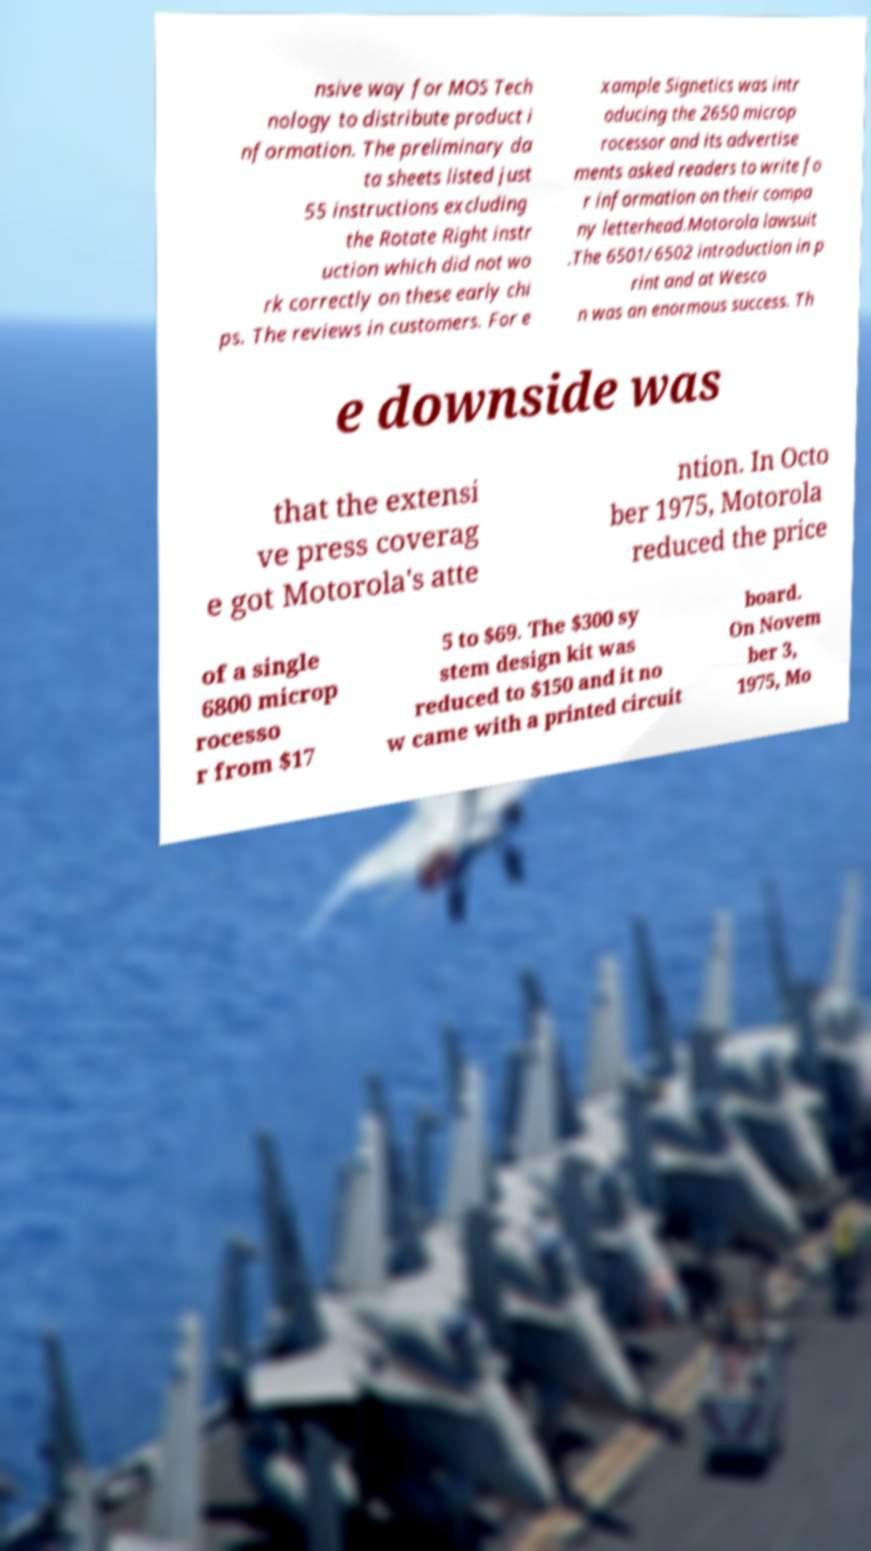Could you extract and type out the text from this image? nsive way for MOS Tech nology to distribute product i nformation. The preliminary da ta sheets listed just 55 instructions excluding the Rotate Right instr uction which did not wo rk correctly on these early chi ps. The reviews in customers. For e xample Signetics was intr oducing the 2650 microp rocessor and its advertise ments asked readers to write fo r information on their compa ny letterhead.Motorola lawsuit .The 6501/6502 introduction in p rint and at Wesco n was an enormous success. Th e downside was that the extensi ve press coverag e got Motorola's atte ntion. In Octo ber 1975, Motorola reduced the price of a single 6800 microp rocesso r from $17 5 to $69. The $300 sy stem design kit was reduced to $150 and it no w came with a printed circuit board. On Novem ber 3, 1975, Mo 